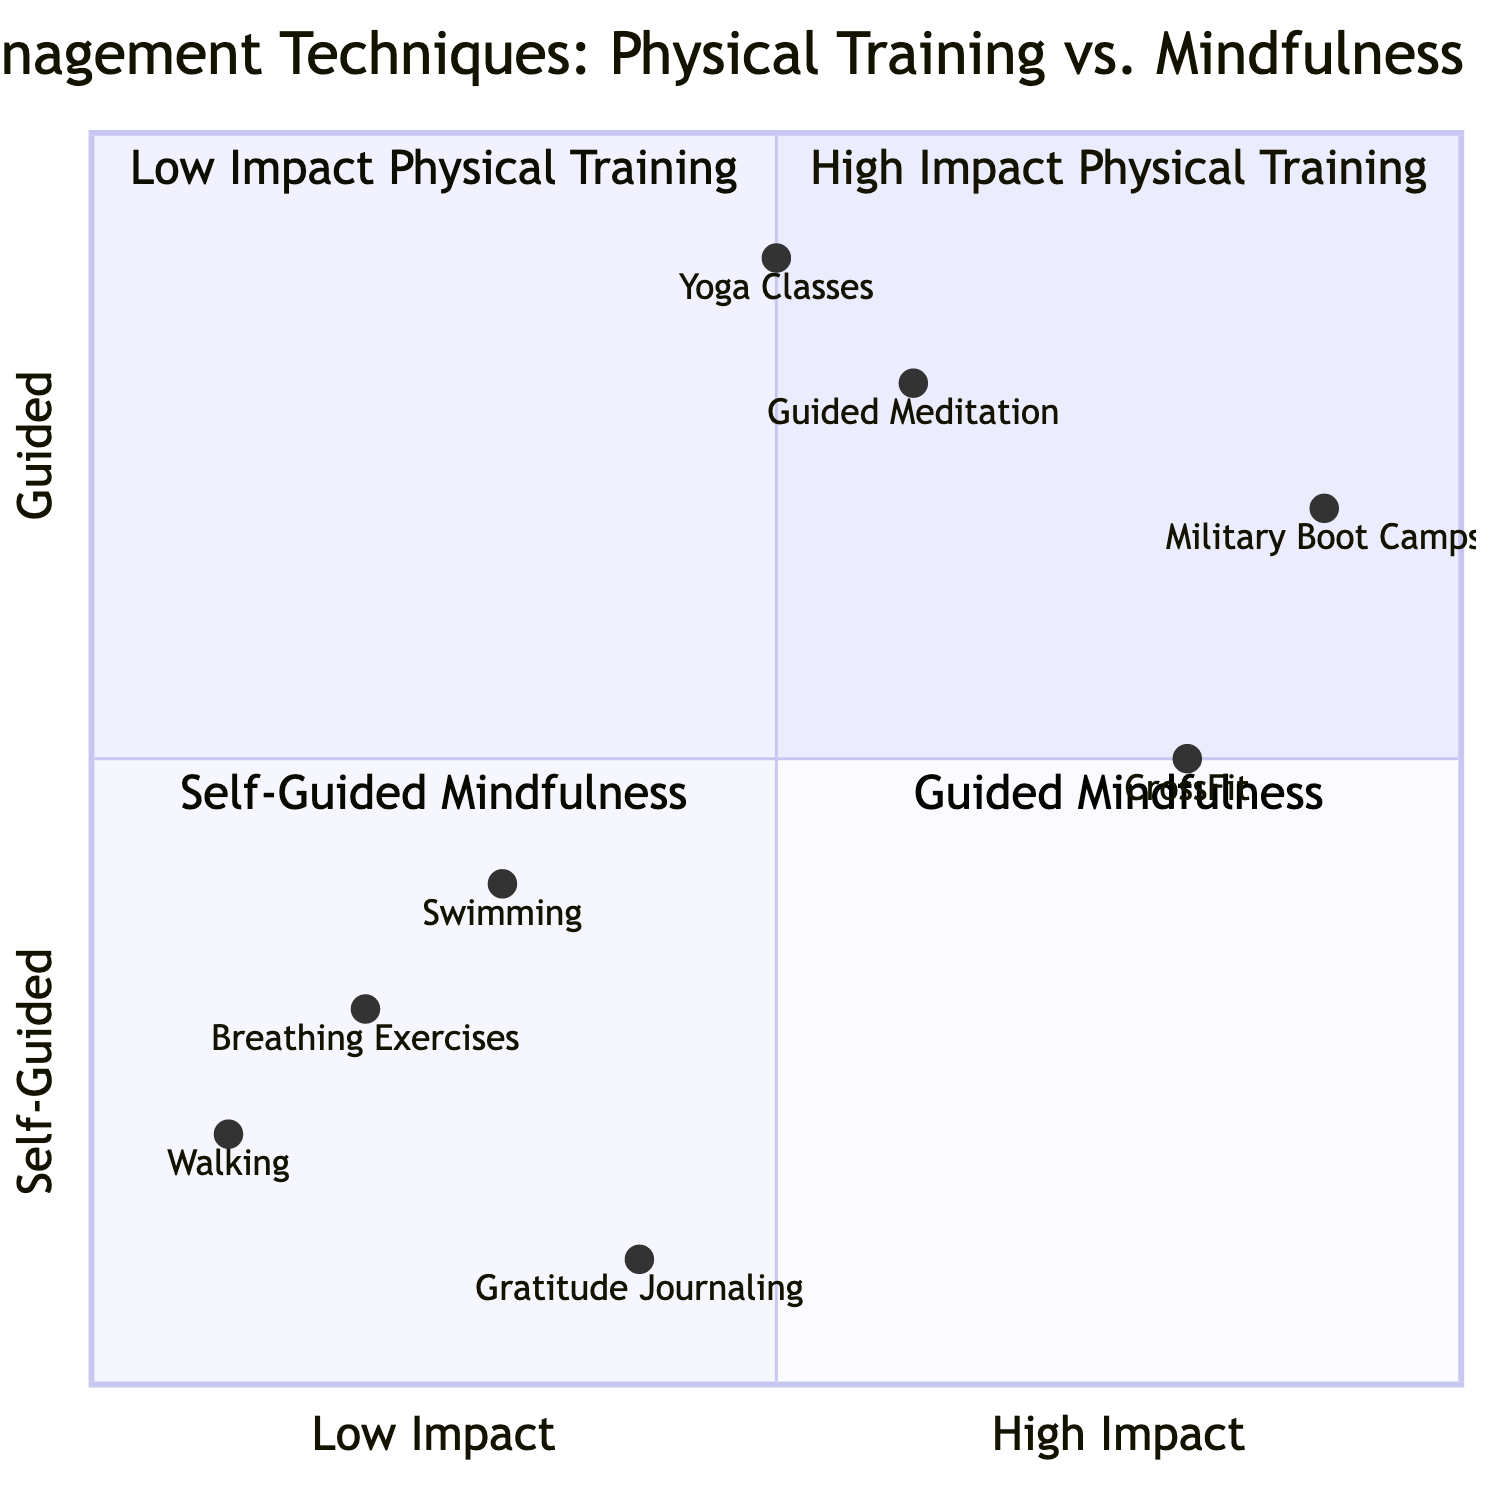What activities are classified under High Impact Physical Training? In the quadrant labeled "High Impact Physical Training," the activities listed are "CrossFit" and "Military Boot Camps."
Answer: CrossFit, Military Boot Camps Which Self-Guided Mindfulness technique is positioned highest on the chart? In the quadrant for "Self-Guided Mindfulness," the activity that is furthest up the chart is "Breathing Exercises." This is determined by its position along the y-axis.
Answer: Breathing Exercises What are the benefits of Yoga Classes? The benefits of "Yoga Classes," as stated in the diagram, are "Flexibility" and "Mental clarity."
Answer: Flexibility, Mental clarity How many techniques are listed under Guided Mindfulness? In the "Guided Mindfulness" quadrant, there are two activities: "Guided Meditation" and "Yoga Classes." Therefore, the total number is 2.
Answer: 2 Which activity has the highest impact among the physical training techniques? Referring to the y-axis of the quadrant chart, "Military Boot Camps," with the coordinates [0.9, 0.7], is the highest compared to other physical training techniques, making it the one with the highest impact.
Answer: Military Boot Camps What are the challenges of Gratitude Journaling? The challenges for "Gratitude Journaling" are "Daily commitment" and "Might feel forced initially," as depicted in the diagram.
Answer: Daily commitment, Might feel forced initially Which physical training activity offers a full-body workout? The activity that is specifically mentioned in the benefits for a full-body workout in the "Low Impact" category is "Swimming."
Answer: Swimming How does the challenge of Guided Meditation compare to that of Yoga Classes? "Guided Meditation" has challenges of "Requires discipline" and "Initial learning curve," while "Yoga Classes" faces challenges of "May need equipment" and "Possible feeling of self-consciousness." Both activities are challenging in different contexts but focus on different aspects.
Answer: Different challenges What is the primary benefit of Breathing Exercises? According to the diagram, the primary benefit of "Breathing Exercises" is "Immediate stress relief," which directly addresses the intended outcomes of the mindfulness practice.
Answer: Immediate stress relief 